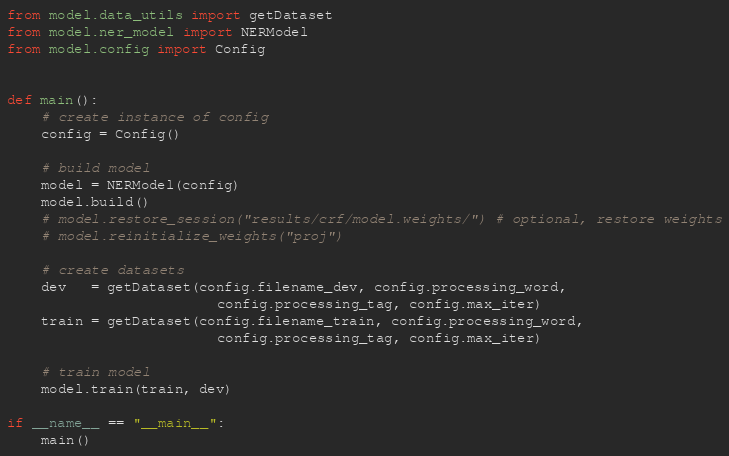<code> <loc_0><loc_0><loc_500><loc_500><_Python_>from model.data_utils import getDataset
from model.ner_model import NERModel
from model.config import Config


def main():
    # create instance of config
    config = Config()

    # build model
    model = NERModel(config)
    model.build()
    # model.restore_session("results/crf/model.weights/") # optional, restore weights
    # model.reinitialize_weights("proj")

    # create datasets
    dev   = getDataset(config.filename_dev, config.processing_word,
                         config.processing_tag, config.max_iter)
    train = getDataset(config.filename_train, config.processing_word,
                         config.processing_tag, config.max_iter)

    # train model
    model.train(train, dev)

if __name__ == "__main__":
    main()
</code> 